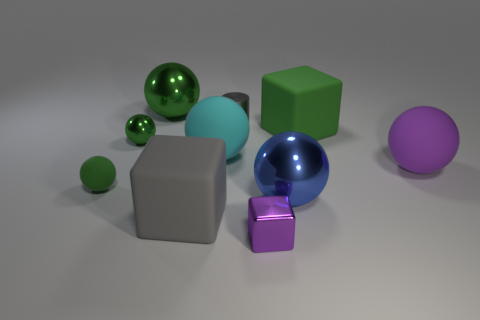How many metallic objects are large yellow spheres or tiny things?
Your response must be concise. 3. There is a green metal ball that is left of the large green metal thing; how big is it?
Provide a succinct answer. Small. There is a cyan sphere that is the same material as the big gray object; what is its size?
Give a very brief answer. Large. How many other tiny metal blocks have the same color as the tiny shiny cube?
Your answer should be very brief. 0. Are any red cylinders visible?
Offer a terse response. No. There is a small green matte object; is it the same shape as the large rubber object that is on the left side of the cyan thing?
Your answer should be very brief. No. There is a big metal object right of the large metallic ball on the left side of the matte cube that is to the left of the shiny block; what color is it?
Give a very brief answer. Blue. Are there any metal balls left of the purple matte ball?
Offer a very short reply. Yes. There is another shiny ball that is the same color as the small metal sphere; what size is it?
Ensure brevity in your answer.  Large. Is there a purple sphere that has the same material as the cyan object?
Your answer should be compact. Yes. 